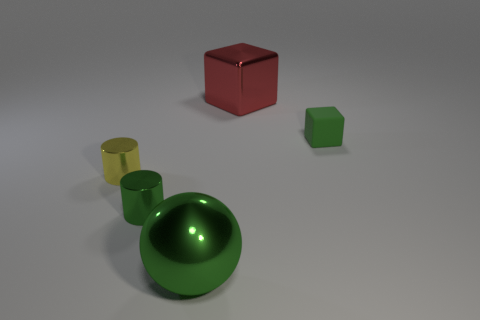Add 2 purple metal balls. How many objects exist? 7 Subtract all spheres. How many objects are left? 4 Subtract all matte objects. Subtract all large red blocks. How many objects are left? 3 Add 1 small matte objects. How many small matte objects are left? 2 Add 4 brown metal spheres. How many brown metal spheres exist? 4 Subtract 1 green spheres. How many objects are left? 4 